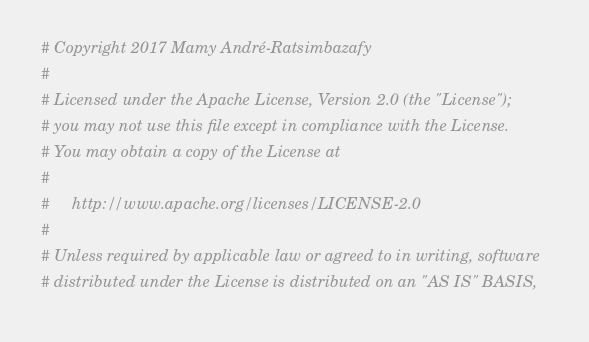Convert code to text. <code><loc_0><loc_0><loc_500><loc_500><_Nim_># Copyright 2017 Mamy André-Ratsimbazafy
#
# Licensed under the Apache License, Version 2.0 (the "License");
# you may not use this file except in compliance with the License.
# You may obtain a copy of the License at
#
#     http://www.apache.org/licenses/LICENSE-2.0
#
# Unless required by applicable law or agreed to in writing, software
# distributed under the License is distributed on an "AS IS" BASIS,</code> 